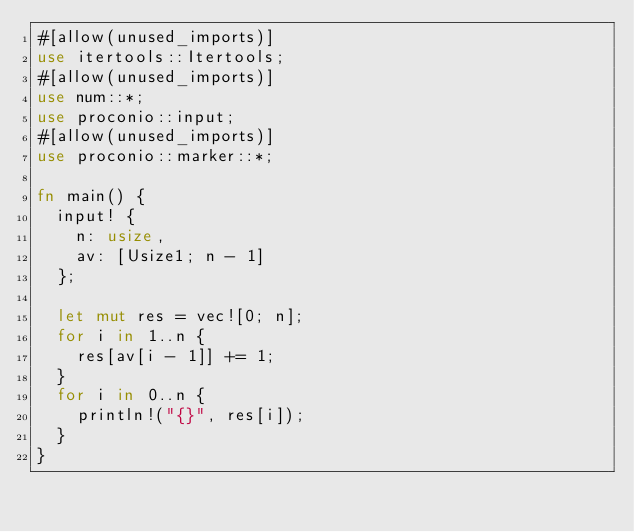<code> <loc_0><loc_0><loc_500><loc_500><_Rust_>#[allow(unused_imports)]
use itertools::Itertools;
#[allow(unused_imports)]
use num::*;
use proconio::input;
#[allow(unused_imports)]
use proconio::marker::*;

fn main() {
  input! {
    n: usize,
    av: [Usize1; n - 1]
  };

  let mut res = vec![0; n];
  for i in 1..n {
    res[av[i - 1]] += 1;
  }
  for i in 0..n {
    println!("{}", res[i]);
  }
}
</code> 